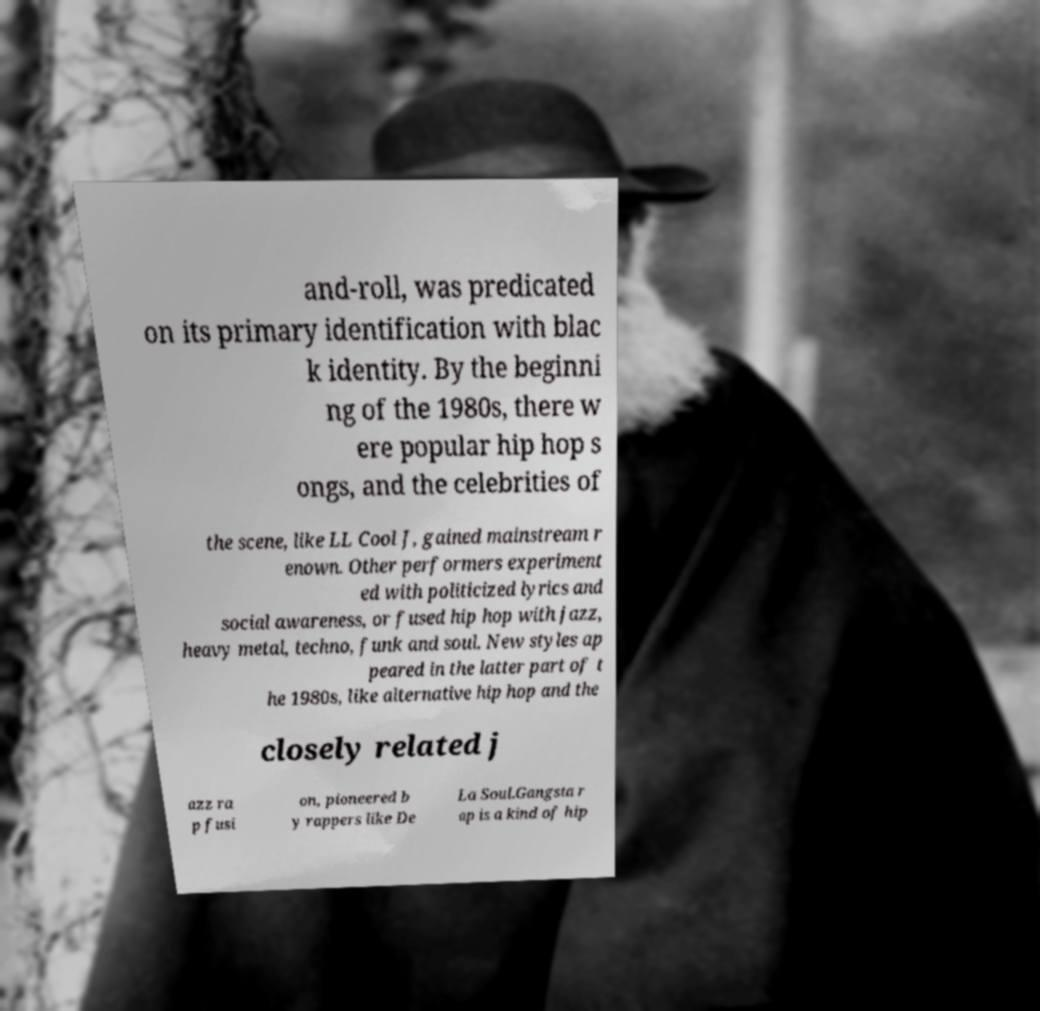Could you assist in decoding the text presented in this image and type it out clearly? and-roll, was predicated on its primary identification with blac k identity. By the beginni ng of the 1980s, there w ere popular hip hop s ongs, and the celebrities of the scene, like LL Cool J, gained mainstream r enown. Other performers experiment ed with politicized lyrics and social awareness, or fused hip hop with jazz, heavy metal, techno, funk and soul. New styles ap peared in the latter part of t he 1980s, like alternative hip hop and the closely related j azz ra p fusi on, pioneered b y rappers like De La Soul.Gangsta r ap is a kind of hip 